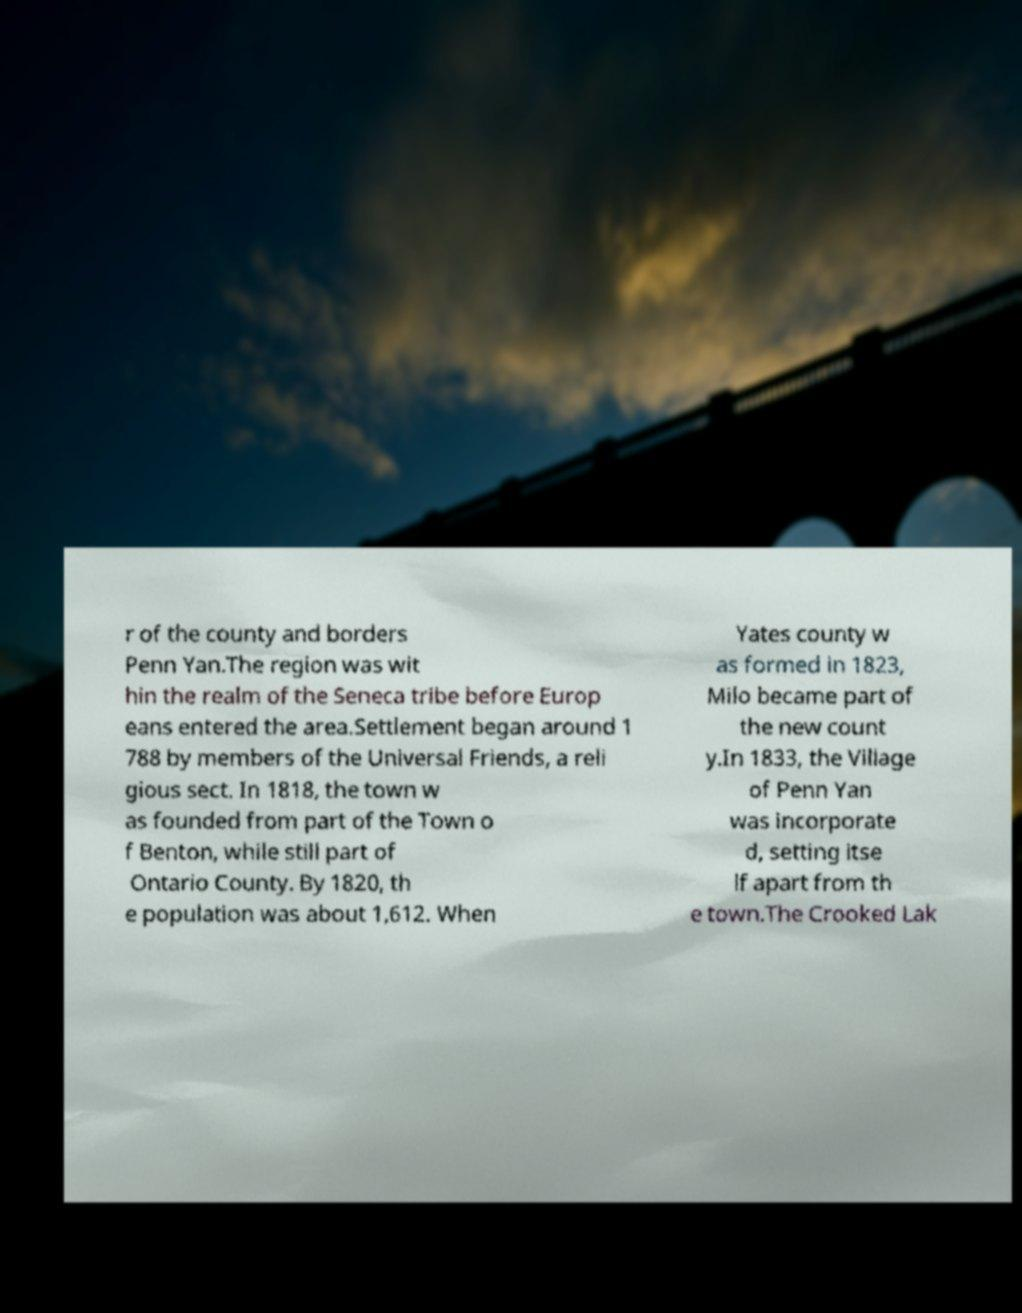For documentation purposes, I need the text within this image transcribed. Could you provide that? r of the county and borders Penn Yan.The region was wit hin the realm of the Seneca tribe before Europ eans entered the area.Settlement began around 1 788 by members of the Universal Friends, a reli gious sect. In 1818, the town w as founded from part of the Town o f Benton, while still part of Ontario County. By 1820, th e population was about 1,612. When Yates county w as formed in 1823, Milo became part of the new count y.In 1833, the Village of Penn Yan was incorporate d, setting itse lf apart from th e town.The Crooked Lak 